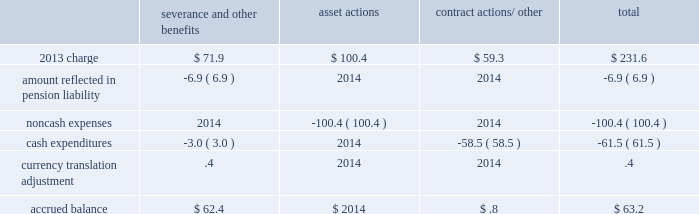Business restructuring and cost reduction plans we recorded charges in 2013 and 2012 for business restructuring and cost reduction plans .
These charges are reflected on the consolidated income statements as 201cbusiness restructuring and cost reduction plans . 201d the charges for these plans have been excluded from segment operating income .
2013 plan during the fourth quarter of 2013 , we recorded an expense of $ 231.6 ( $ 157.9 after-tax , or $ .74 per share ) reflecting actions to better align our cost structure with current market conditions .
These charges include $ 100.4 for asset actions and $ 58.5 for the final settlement of a long-term take-or-pay silane contract primarily impacting the electronics business due to continued weakness in the photovoltaic ( pv ) and light-emitting diode ( led ) markets .
In addition , $ 71.9 was recorded for severance , benefits , and other contractual obligations associated with the elimination of approximately 700 positions and executive changes .
These charges primarily impact our merchant gases businesses and corporate functions .
The actions are in response to weaker than expected business conditions in europe and asia , reorganization of our operations and functional areas , and previously announced senior executive changes .
The planned actions are expected to be completed by the end of fiscal year 2014 .
The 2013 charges relate to the businesses at the segment level as follows : $ 61.0 in merchant gases , $ 28.6 in tonnage gases , $ 141.0 in electronics and performance materials , and $ 1.0 in equipment and energy .
The table summarizes the carrying amount of the accrual for the 2013 plan at 30 september 2013 : severance and other benefits actions contract actions/ other total .
2012 plans in 2012 , we recorded an expense of $ 327.4 ( $ 222.4 after-tax , or $ 1.03 per share ) for business restructuring and cost reduction plans in our polyurethane intermediates ( pui ) , electronics , and european merchant businesses .
During the second quarter of 2012 , we recorded an expense of $ 86.8 ( $ 60.6 after-tax , or $ .28 per share ) for actions to remove stranded costs resulting from our decision to exit the homecare business , the reorganization of the merchant business , and actions to right-size our european cost structure in light of the challenging economic outlook .
The charge related to the businesses at the segment level as follows : $ 77.3 in merchant gases , $ 3.8 in tonnage gases , and $ 5.7 in electronics and performance materials .
As of 30 september 2013 , the planned actions were completed .
During the fourth quarter of 2012 , we took actions to exit the pui business to improve costs , resulting in a net expense of $ 54.6 ( $ 34.8 after-tax , or $ .16 per share ) .
We sold certain assets and the rights to a supply contract for $ 32.7 in cash at closing .
In connection with these actions , we recognized an expense of $ 26.6 , for the net book value of assets sold and those committed to be disposed of other than by sale .
The remaining charge was primarily related to contract terminations and an environmental liability .
Our pui production facility in pasadena , texas is currently being dismantled , with completion expected in fiscal year 2014 .
The costs to dismantle are expensed as incurred and reflected in continuing operations in the tonnage gases business segment .
During the fourth quarter of 2012 , we completed an assessment of our position in the pv market , resulting in $ 186.0 of expense ( $ 127.0 after-tax , or $ .59 per share ) primarily related to the electronics and performance materials segment .
Air products supplies the pv market with both bulk and on-site supply of gases , including silane .
The pv market has not developed as expected , and as a result , the market capacity to produce silane is expected to exceed demand for the foreseeable future .
Included in the charge was an accrual of $ 93.5 for an offer that we made to terminate a long-term take-or-pay contract to purchase silane .
A final settlement was reached with the supplier in the fourth quarter of 2013. .
Considering the 2013 charge , what is the impact of the merchant gases segment on the total charge? 
Rationale: it is the value of the merchant gases segment divided by the total charge , then turned into a percentage .
Computations: (61.0 / 231.6)
Answer: 0.26339. Business restructuring and cost reduction plans we recorded charges in 2013 and 2012 for business restructuring and cost reduction plans .
These charges are reflected on the consolidated income statements as 201cbusiness restructuring and cost reduction plans . 201d the charges for these plans have been excluded from segment operating income .
2013 plan during the fourth quarter of 2013 , we recorded an expense of $ 231.6 ( $ 157.9 after-tax , or $ .74 per share ) reflecting actions to better align our cost structure with current market conditions .
These charges include $ 100.4 for asset actions and $ 58.5 for the final settlement of a long-term take-or-pay silane contract primarily impacting the electronics business due to continued weakness in the photovoltaic ( pv ) and light-emitting diode ( led ) markets .
In addition , $ 71.9 was recorded for severance , benefits , and other contractual obligations associated with the elimination of approximately 700 positions and executive changes .
These charges primarily impact our merchant gases businesses and corporate functions .
The actions are in response to weaker than expected business conditions in europe and asia , reorganization of our operations and functional areas , and previously announced senior executive changes .
The planned actions are expected to be completed by the end of fiscal year 2014 .
The 2013 charges relate to the businesses at the segment level as follows : $ 61.0 in merchant gases , $ 28.6 in tonnage gases , $ 141.0 in electronics and performance materials , and $ 1.0 in equipment and energy .
The table summarizes the carrying amount of the accrual for the 2013 plan at 30 september 2013 : severance and other benefits actions contract actions/ other total .
2012 plans in 2012 , we recorded an expense of $ 327.4 ( $ 222.4 after-tax , or $ 1.03 per share ) for business restructuring and cost reduction plans in our polyurethane intermediates ( pui ) , electronics , and european merchant businesses .
During the second quarter of 2012 , we recorded an expense of $ 86.8 ( $ 60.6 after-tax , or $ .28 per share ) for actions to remove stranded costs resulting from our decision to exit the homecare business , the reorganization of the merchant business , and actions to right-size our european cost structure in light of the challenging economic outlook .
The charge related to the businesses at the segment level as follows : $ 77.3 in merchant gases , $ 3.8 in tonnage gases , and $ 5.7 in electronics and performance materials .
As of 30 september 2013 , the planned actions were completed .
During the fourth quarter of 2012 , we took actions to exit the pui business to improve costs , resulting in a net expense of $ 54.6 ( $ 34.8 after-tax , or $ .16 per share ) .
We sold certain assets and the rights to a supply contract for $ 32.7 in cash at closing .
In connection with these actions , we recognized an expense of $ 26.6 , for the net book value of assets sold and those committed to be disposed of other than by sale .
The remaining charge was primarily related to contract terminations and an environmental liability .
Our pui production facility in pasadena , texas is currently being dismantled , with completion expected in fiscal year 2014 .
The costs to dismantle are expensed as incurred and reflected in continuing operations in the tonnage gases business segment .
During the fourth quarter of 2012 , we completed an assessment of our position in the pv market , resulting in $ 186.0 of expense ( $ 127.0 after-tax , or $ .59 per share ) primarily related to the electronics and performance materials segment .
Air products supplies the pv market with both bulk and on-site supply of gases , including silane .
The pv market has not developed as expected , and as a result , the market capacity to produce silane is expected to exceed demand for the foreseeable future .
Included in the charge was an accrual of $ 93.5 for an offer that we made to terminate a long-term take-or-pay contract to purchase silane .
A final settlement was reached with the supplier in the fourth quarter of 2013. .
Considering the 2013 charge , what is the percentage of the asset actions on the total charge? 
Rationale: it is the value of the asset actions divided by the total charge , then turned into a percentage .
Computations: (100.4 / 231.6)
Answer: 0.43351. 